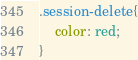<code> <loc_0><loc_0><loc_500><loc_500><_CSS_>.session-delete{
    color: red;
}</code> 